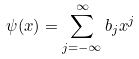<formula> <loc_0><loc_0><loc_500><loc_500>\psi ( x ) = \sum _ { j = - \infty } ^ { \infty } b _ { j } x ^ { j }</formula> 